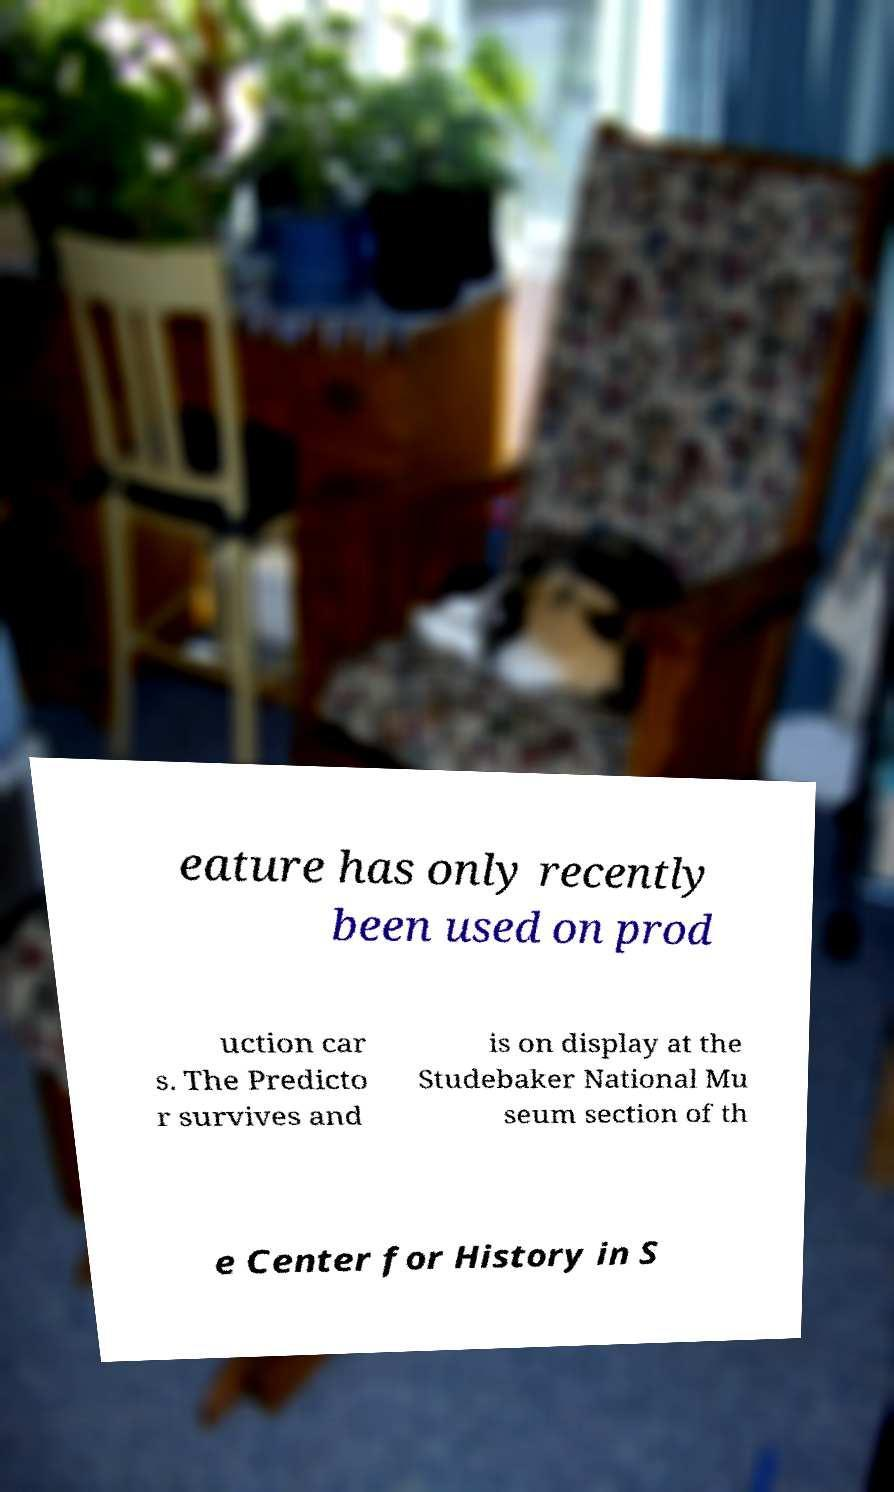Can you read and provide the text displayed in the image?This photo seems to have some interesting text. Can you extract and type it out for me? eature has only recently been used on prod uction car s. The Predicto r survives and is on display at the Studebaker National Mu seum section of th e Center for History in S 